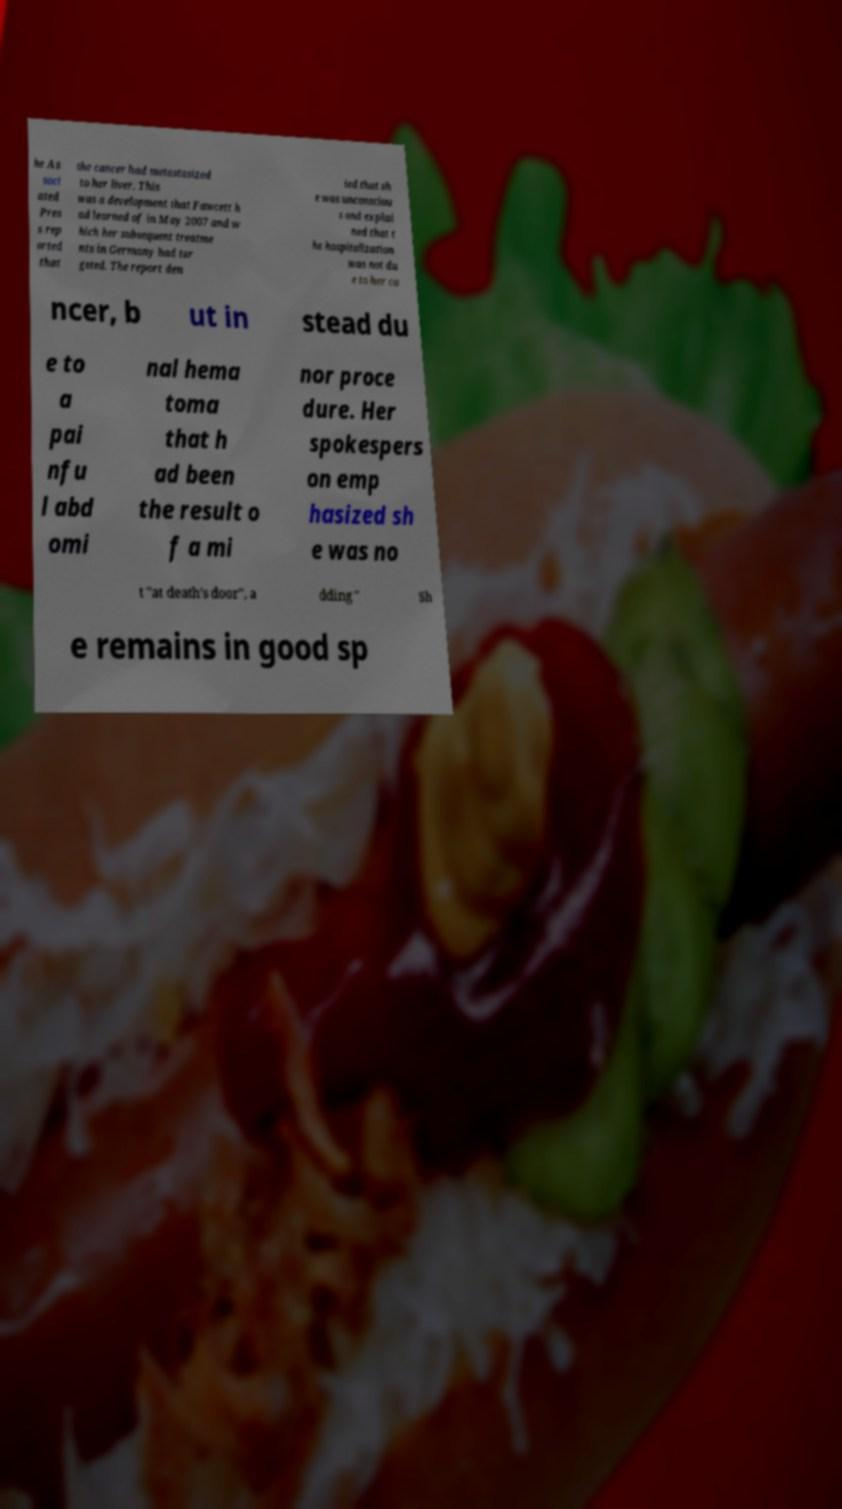Please identify and transcribe the text found in this image. he As soci ated Pres s rep orted that the cancer had metastasized to her liver. This was a development that Fawcett h ad learned of in May 2007 and w hich her subsequent treatme nts in Germany had tar geted. The report den ied that sh e was unconsciou s and explai ned that t he hospitalization was not du e to her ca ncer, b ut in stead du e to a pai nfu l abd omi nal hema toma that h ad been the result o f a mi nor proce dure. Her spokespers on emp hasized sh e was no t "at death's door", a dding " Sh e remains in good sp 